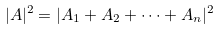Convert formula to latex. <formula><loc_0><loc_0><loc_500><loc_500>| A | ^ { 2 } = | A _ { 1 } + A _ { 2 } + \dots + A _ { n } | ^ { 2 }</formula> 